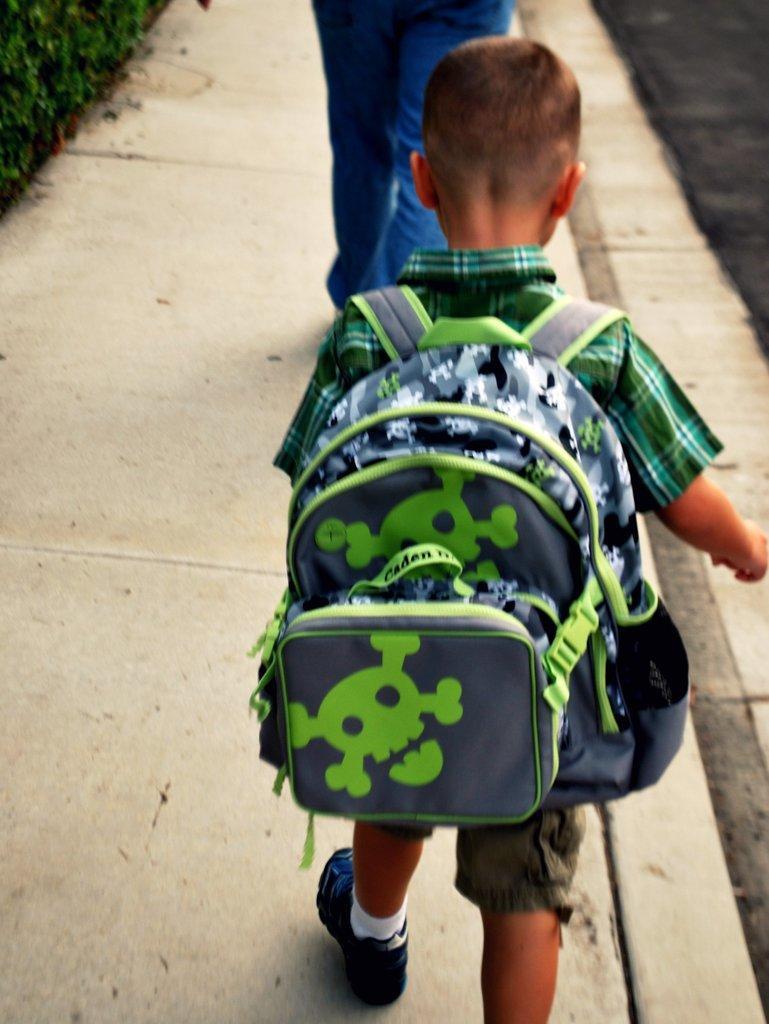Describe this image in one or two sentences. As we can see in the image there is a boy walking and wearing green color bag. 